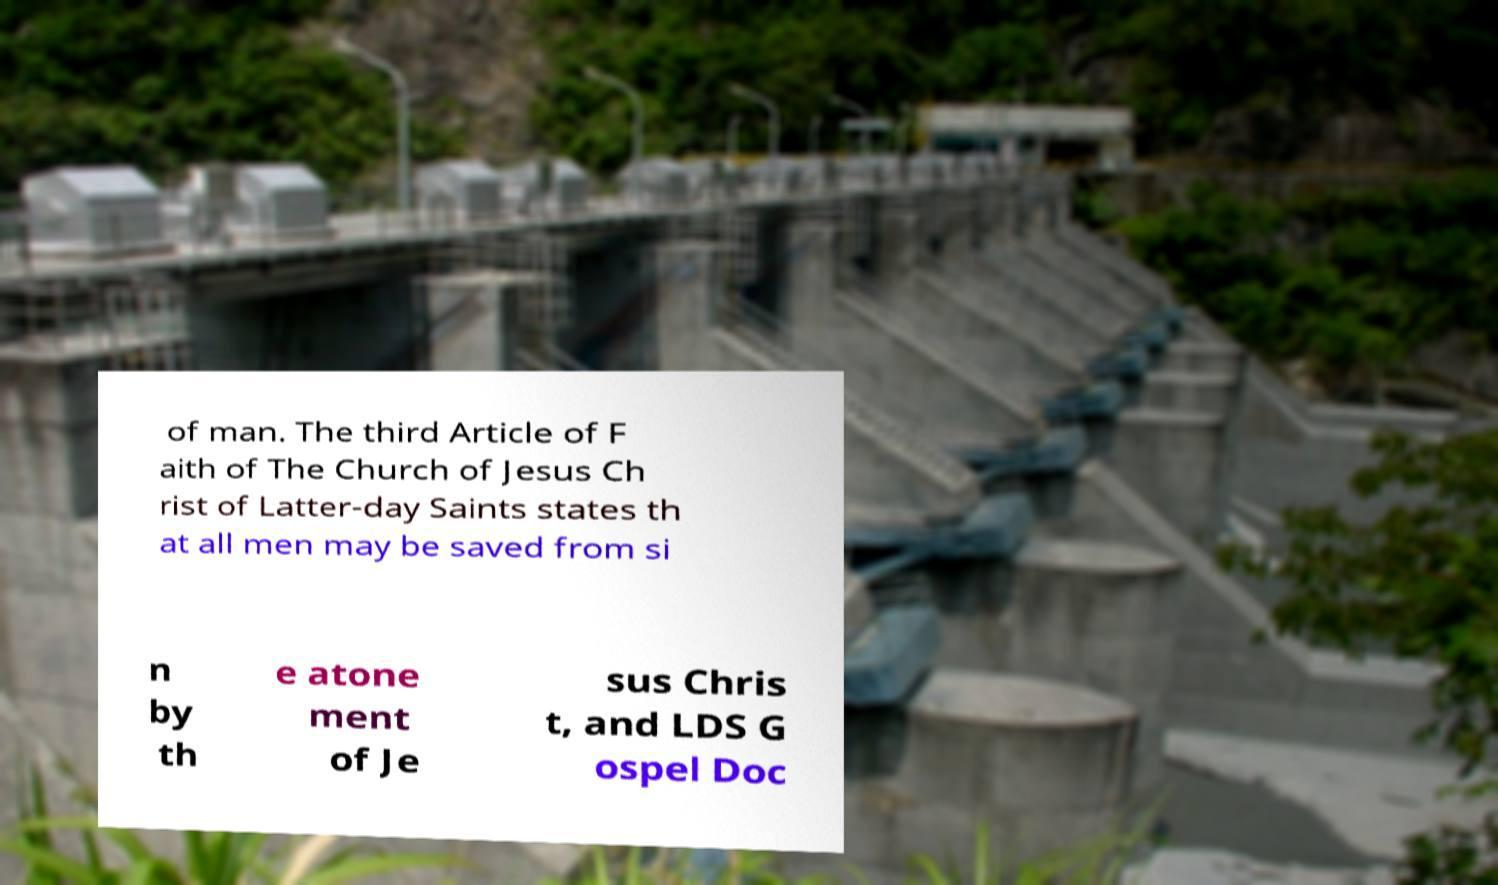Can you read and provide the text displayed in the image?This photo seems to have some interesting text. Can you extract and type it out for me? of man. The third Article of F aith of The Church of Jesus Ch rist of Latter-day Saints states th at all men may be saved from si n by th e atone ment of Je sus Chris t, and LDS G ospel Doc 